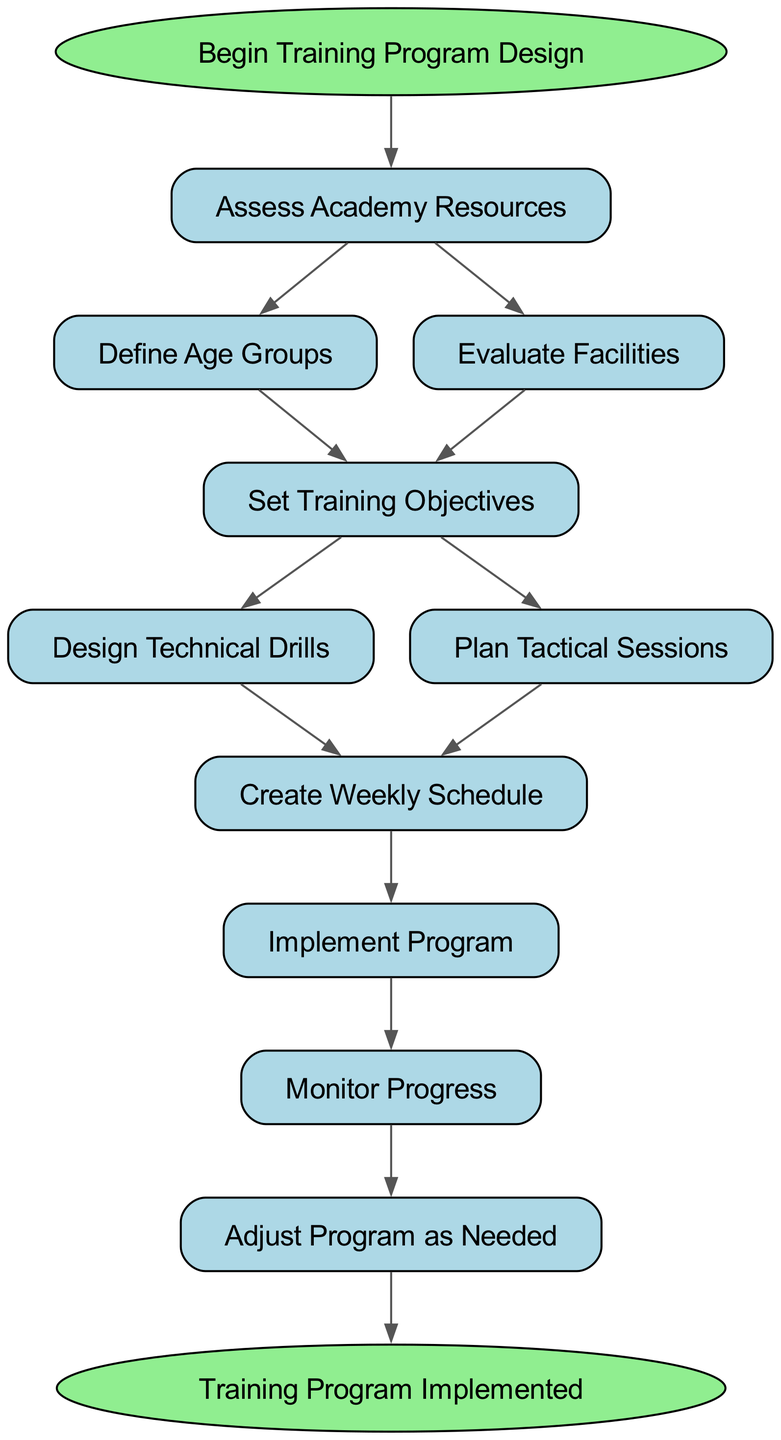What is the first step in the training program design? The first step is marked by the start node labeled "Begin Training Program Design". The diagram indicates that this is where the process begins before any actions or assessments are taken.
Answer: Assess Academy Resources How many elements are in the training program design flowchart? The diagram lists a total of 10 elements, including the start and end points. Counting all the nodes from "Assess Academy Resources" to "Adjust Program as Needed" gives a total of 10.
Answer: 10 What comes after implementing the program? The flow of the diagram shows that after "Implement Program," the next step is "Monitor Progress." This is a direct connection as indicated by the edge leading from "Implement Program" to "Monitor Progress."
Answer: Monitor Progress Which step follows evaluating the facilities? From the node labeled "Evaluate Facilities," the next step directly listed in the diagram is "Set Training Objectives." This indicates the immediate progression after evaluating facilities.
Answer: Set Training Objectives What are the two paths that can be taken after setting training objectives? After "Set Training Objectives," the diagram branches into two options: "Design Technical Drills" and "Plan Tactical Sessions." This means there are two different actions that can be taken once objectives are set.
Answer: Design Technical Drills, Plan Tactical Sessions What is the final outcome of the training program design? The end node of the diagram indicates that the final outcome after following all the steps is "Training Program Implemented." This signifies the completion of the entire process laid out by the flowchart.
Answer: Training Program Implemented What is the relationship between "Define Age Groups" and "Evaluate Facilities"? Both "Define Age Groups" and "Evaluate Facilities" share a direct connection to the node "Set Training Objectives." This means they are two different assessments that lead to the same subsequent step in the flowchart.
Answer: Both lead to Set Training Objectives How many technical drills are designed before creating the weekly schedule? According to the flowchart, "Design Technical Drills" is a step that occurs before "Create Weekly Schedule." However, the diagram does not specify a number of technical drills; it only presents the order of actions.
Answer: Not specified 